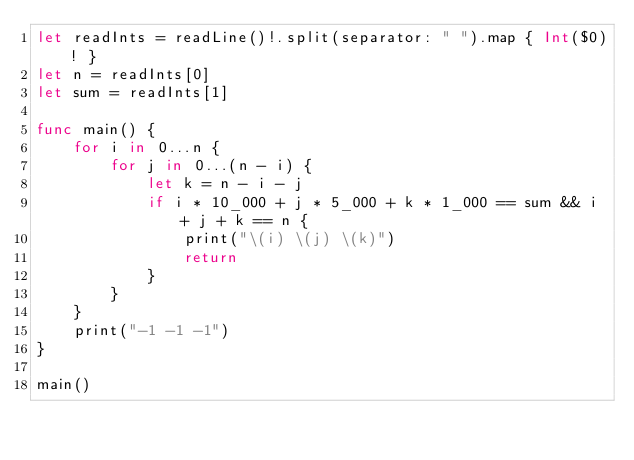Convert code to text. <code><loc_0><loc_0><loc_500><loc_500><_Swift_>let readInts = readLine()!.split(separator: " ").map { Int($0)! }
let n = readInts[0]
let sum = readInts[1]

func main() {
    for i in 0...n {
        for j in 0...(n - i) {
            let k = n - i - j
            if i * 10_000 + j * 5_000 + k * 1_000 == sum && i + j + k == n {
                print("\(i) \(j) \(k)")
                return
            }
        }
    }
    print("-1 -1 -1")
}

main()</code> 